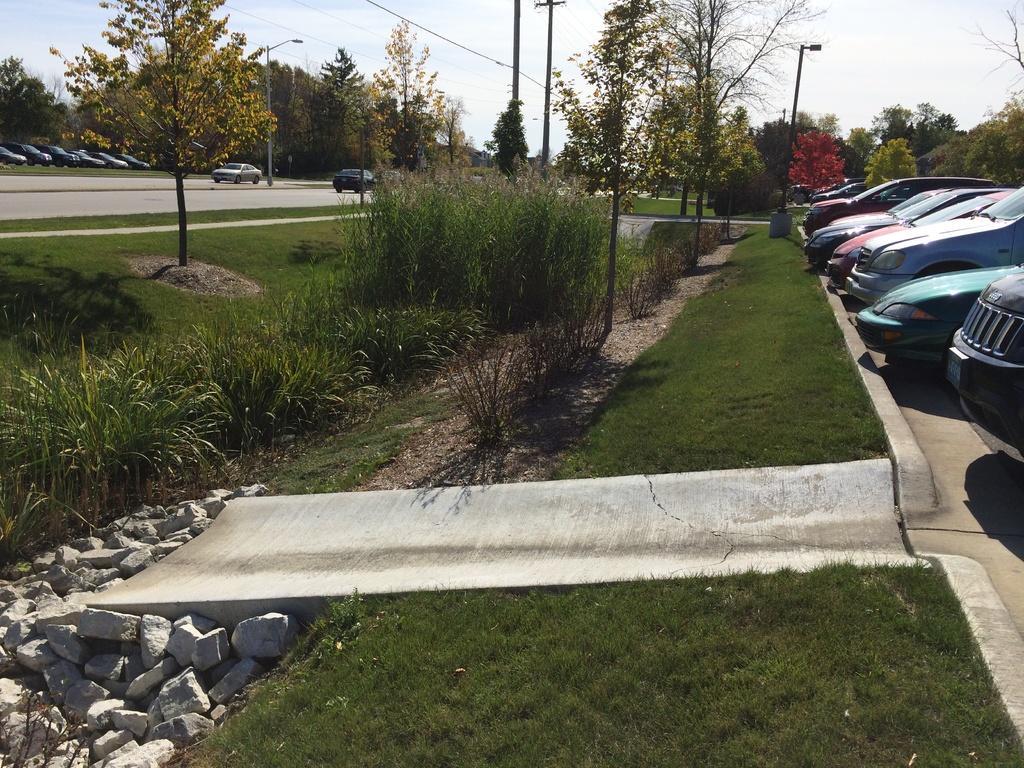In one or two sentences, can you explain what this image depicts? In this picture we can see cars on the road, trees, grass, stones, poles and in the background we can see sky. 